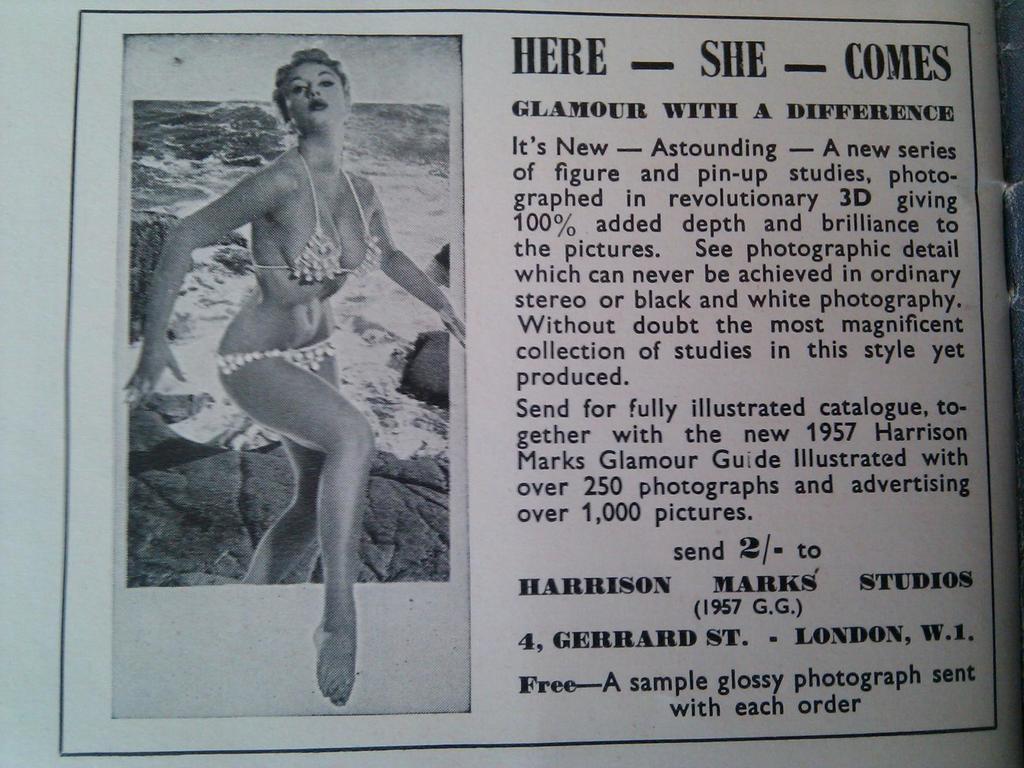Can you describe this image briefly? In this image there is a paper and we can see a picture of a lady printed on the paper. We can see text. 